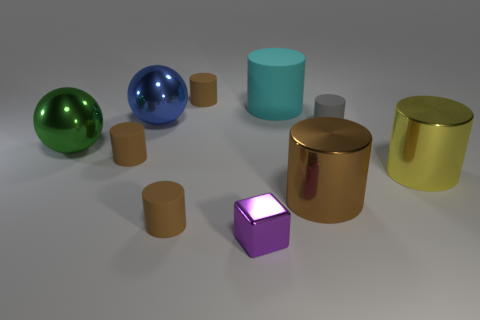The big ball that is in front of the blue metal thing is what color?
Make the answer very short. Green. There is a big thing in front of the big object that is on the right side of the big brown metallic cylinder; what is its material?
Offer a terse response. Metal. What shape is the gray matte object?
Make the answer very short. Cylinder. What is the material of the other thing that is the same shape as the big blue object?
Offer a terse response. Metal. What number of green spheres have the same size as the brown metallic cylinder?
Make the answer very short. 1. Is there a green shiny sphere behind the brown rubber object behind the large cyan cylinder?
Your response must be concise. No. What number of brown things are shiny cylinders or large rubber objects?
Your answer should be compact. 1. What color is the big rubber cylinder?
Provide a succinct answer. Cyan. There is a cyan cylinder that is made of the same material as the tiny gray object; what is its size?
Provide a short and direct response. Large. What number of large cyan things have the same shape as the large yellow thing?
Provide a succinct answer. 1. 